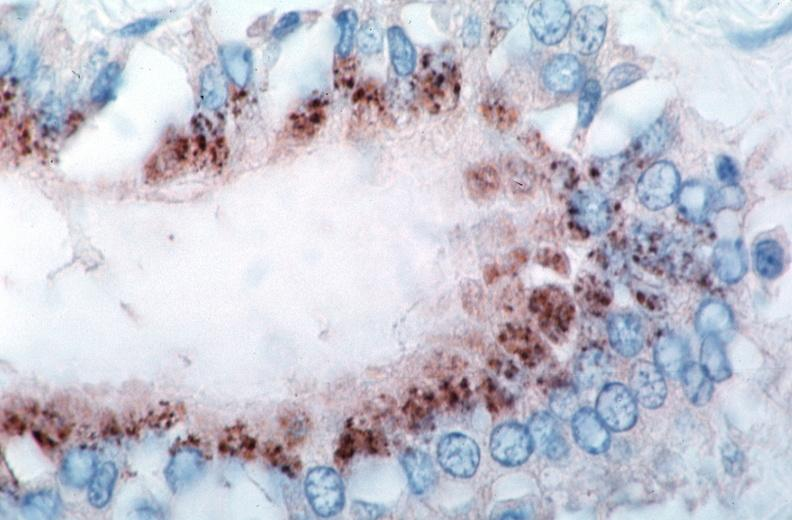what spotted fever, immunoperoxidase staining vessels for rickettsia rickettsii?
Answer the question using a single word or phrase. Rocky mountain 